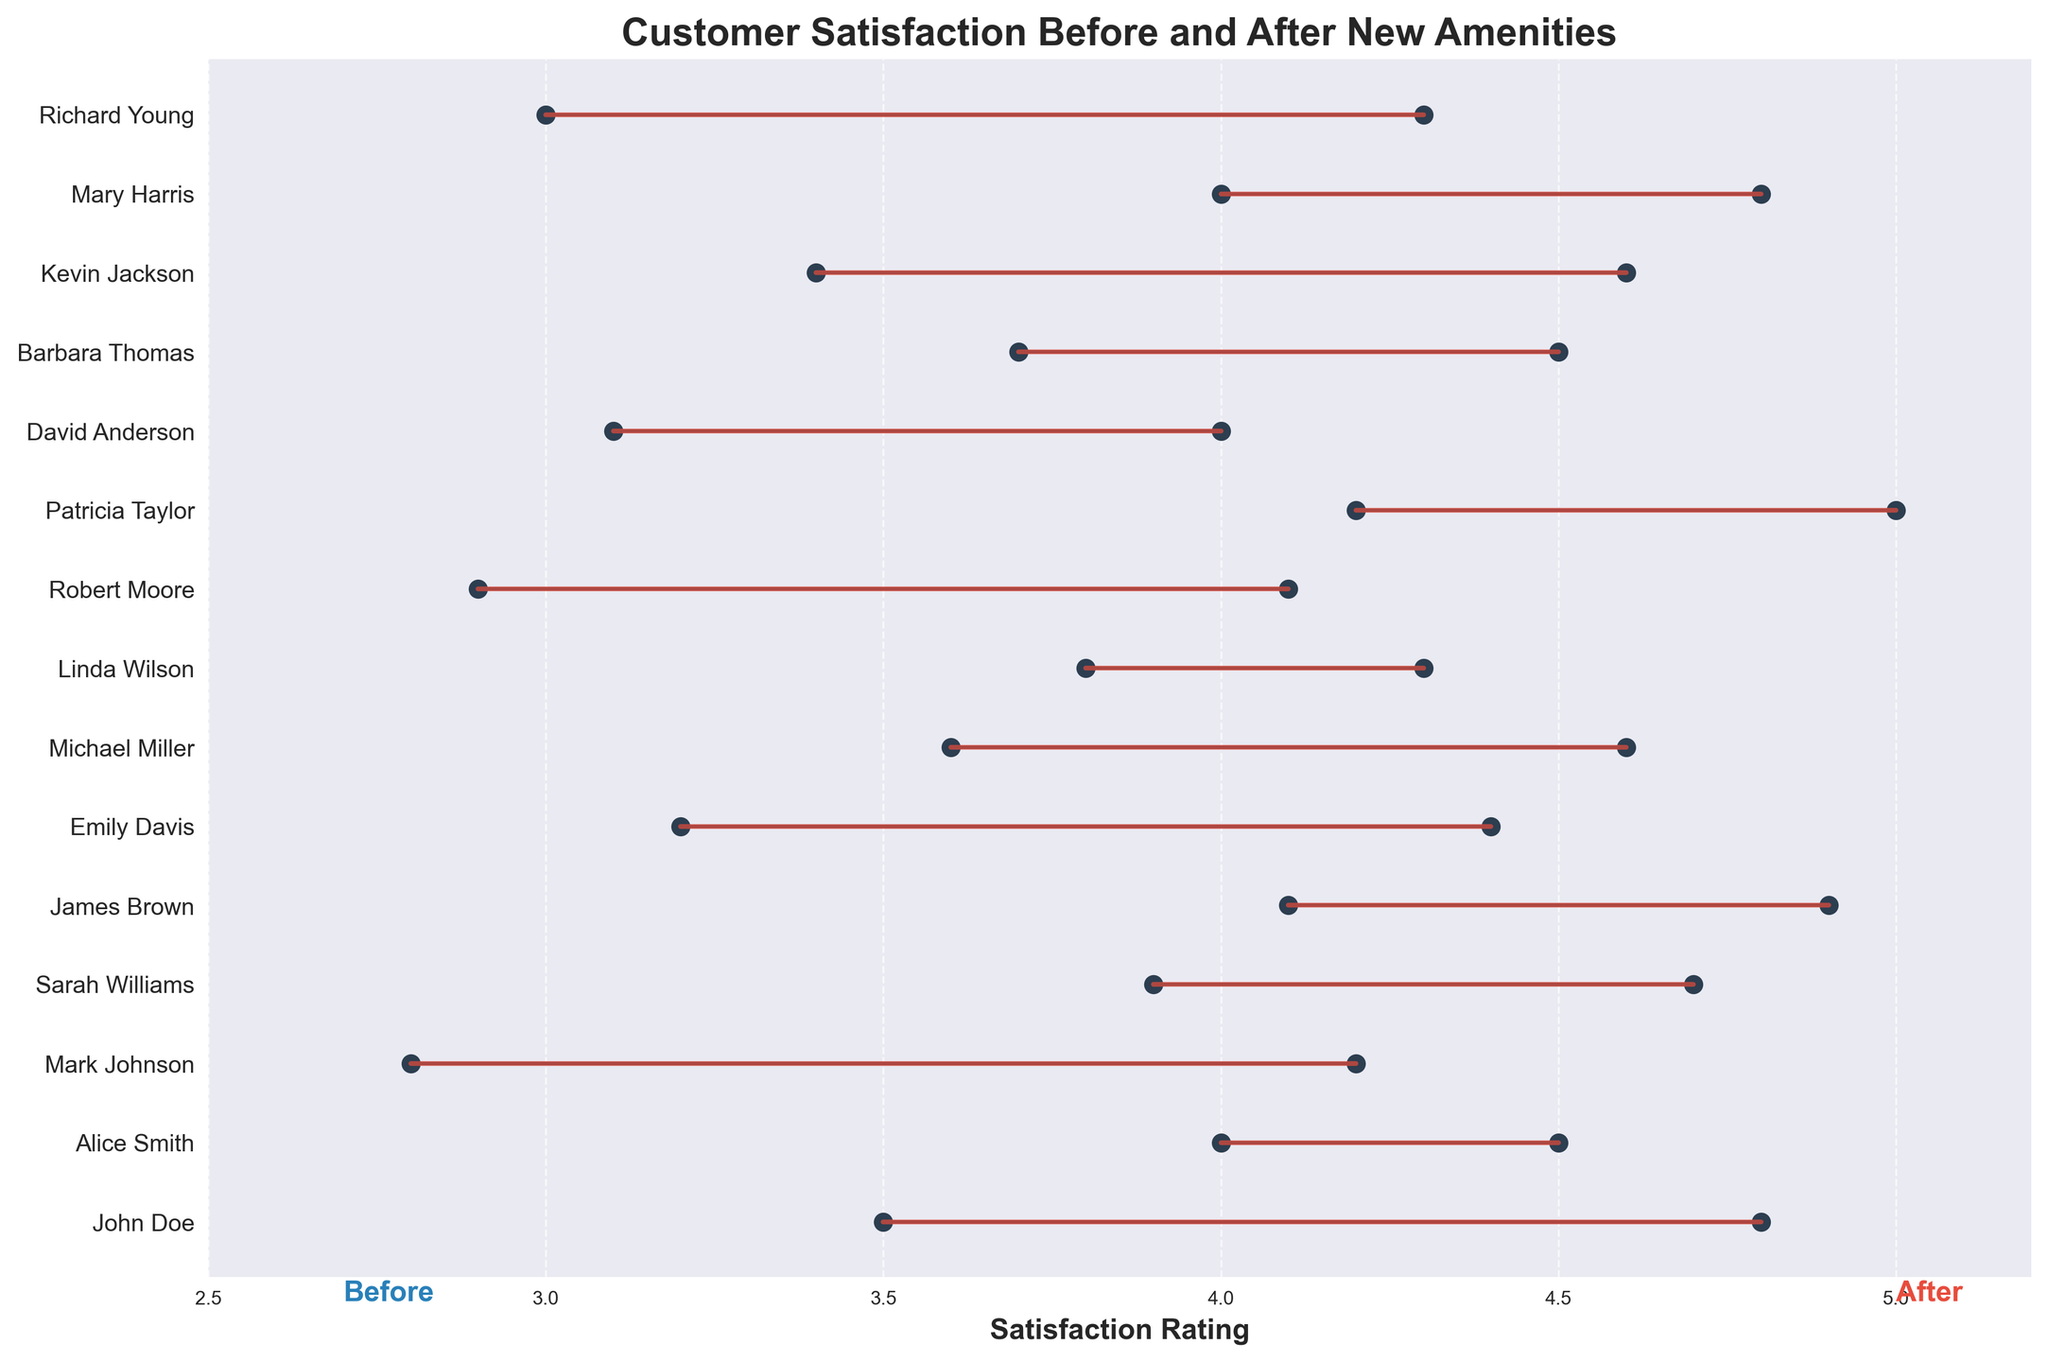How many customers rated their satisfaction as 4.5 before the new amenities? The figure shows the customers' satisfaction ratings before and after. By looking at the 'before' (left side), only "Alice Smith" and "Barbara Thomas" have a rating of 4.0, not 4.5
Answer: 0 Which customer had the biggest increase in satisfaction rating? By comparing the lengths of the lines between 'before' and 'after' ratings, "John Doe" had the largest increase from 3.5 to 4.8 (1.3 increase)
Answer: John Doe What is the average satisfaction rating after the new amenities were introduced? Adding up all the 'after' ratings: 4.8 + 4.5 + 4.2 + 4.7 + 4.9 + 4.4 + 4.6 + 4.3 + 4.1 + 5.0 + 4.0 + 4.5 + 4.6 + 4.8 + 4.3 = 67.7, then dividing it by the number of customers (15): 67.7 / 15
Answer: 4.51 How many customers are there in total? Counting the y-ticks labeled with customer names, there are 15 ticks corresponding to 15 customers
Answer: 15 Did any customer have a satisfaction rating decrease after introducing the new amenities? Looking at the figure, all lines either stay the same or increase from 'before' to 'after'. No lines show a decrease
Answer: No What was the satisfaction rating for Sarah Williams before and after introducing the new amenities? From the y-axis labels, Sarah Williams's line starts at 3.9 before and goes to 4.7 after
Answer: Before: 3.9, After: 4.7 Which customer had the smallest change in satisfaction? By visually comparing the lengths of the lines connecting 'before' and 'after', "Alice Smith" had the smallest change, only from 4.0 to 4.5 (0.5 increase)
Answer: Alice Smith 